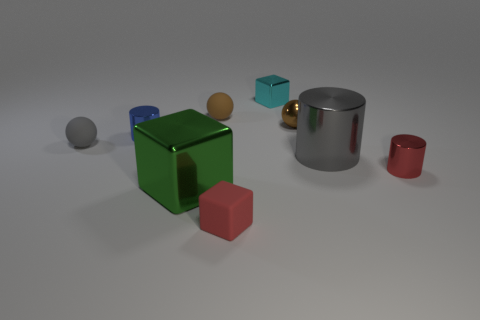There is a green cube that is made of the same material as the blue cylinder; what size is it?
Your answer should be very brief. Large. What is the size of the gray rubber sphere in front of the tiny cylinder that is on the left side of the red metallic cylinder?
Your answer should be compact. Small. How many other things are the same color as the matte cube?
Your response must be concise. 1. What is the material of the small gray ball?
Your answer should be compact. Rubber. Are there any cyan metal things?
Offer a terse response. Yes. Is the number of large cubes that are left of the blue thing the same as the number of large blue blocks?
Make the answer very short. Yes. How many tiny objects are red cylinders or cyan matte cylinders?
Offer a terse response. 1. What shape is the thing that is the same color as the small rubber block?
Keep it short and to the point. Cylinder. Is the tiny cylinder on the left side of the small red shiny object made of the same material as the small gray ball?
Keep it short and to the point. No. There is a gray object that is left of the cube that is behind the large green shiny thing; what is its material?
Ensure brevity in your answer.  Rubber. 